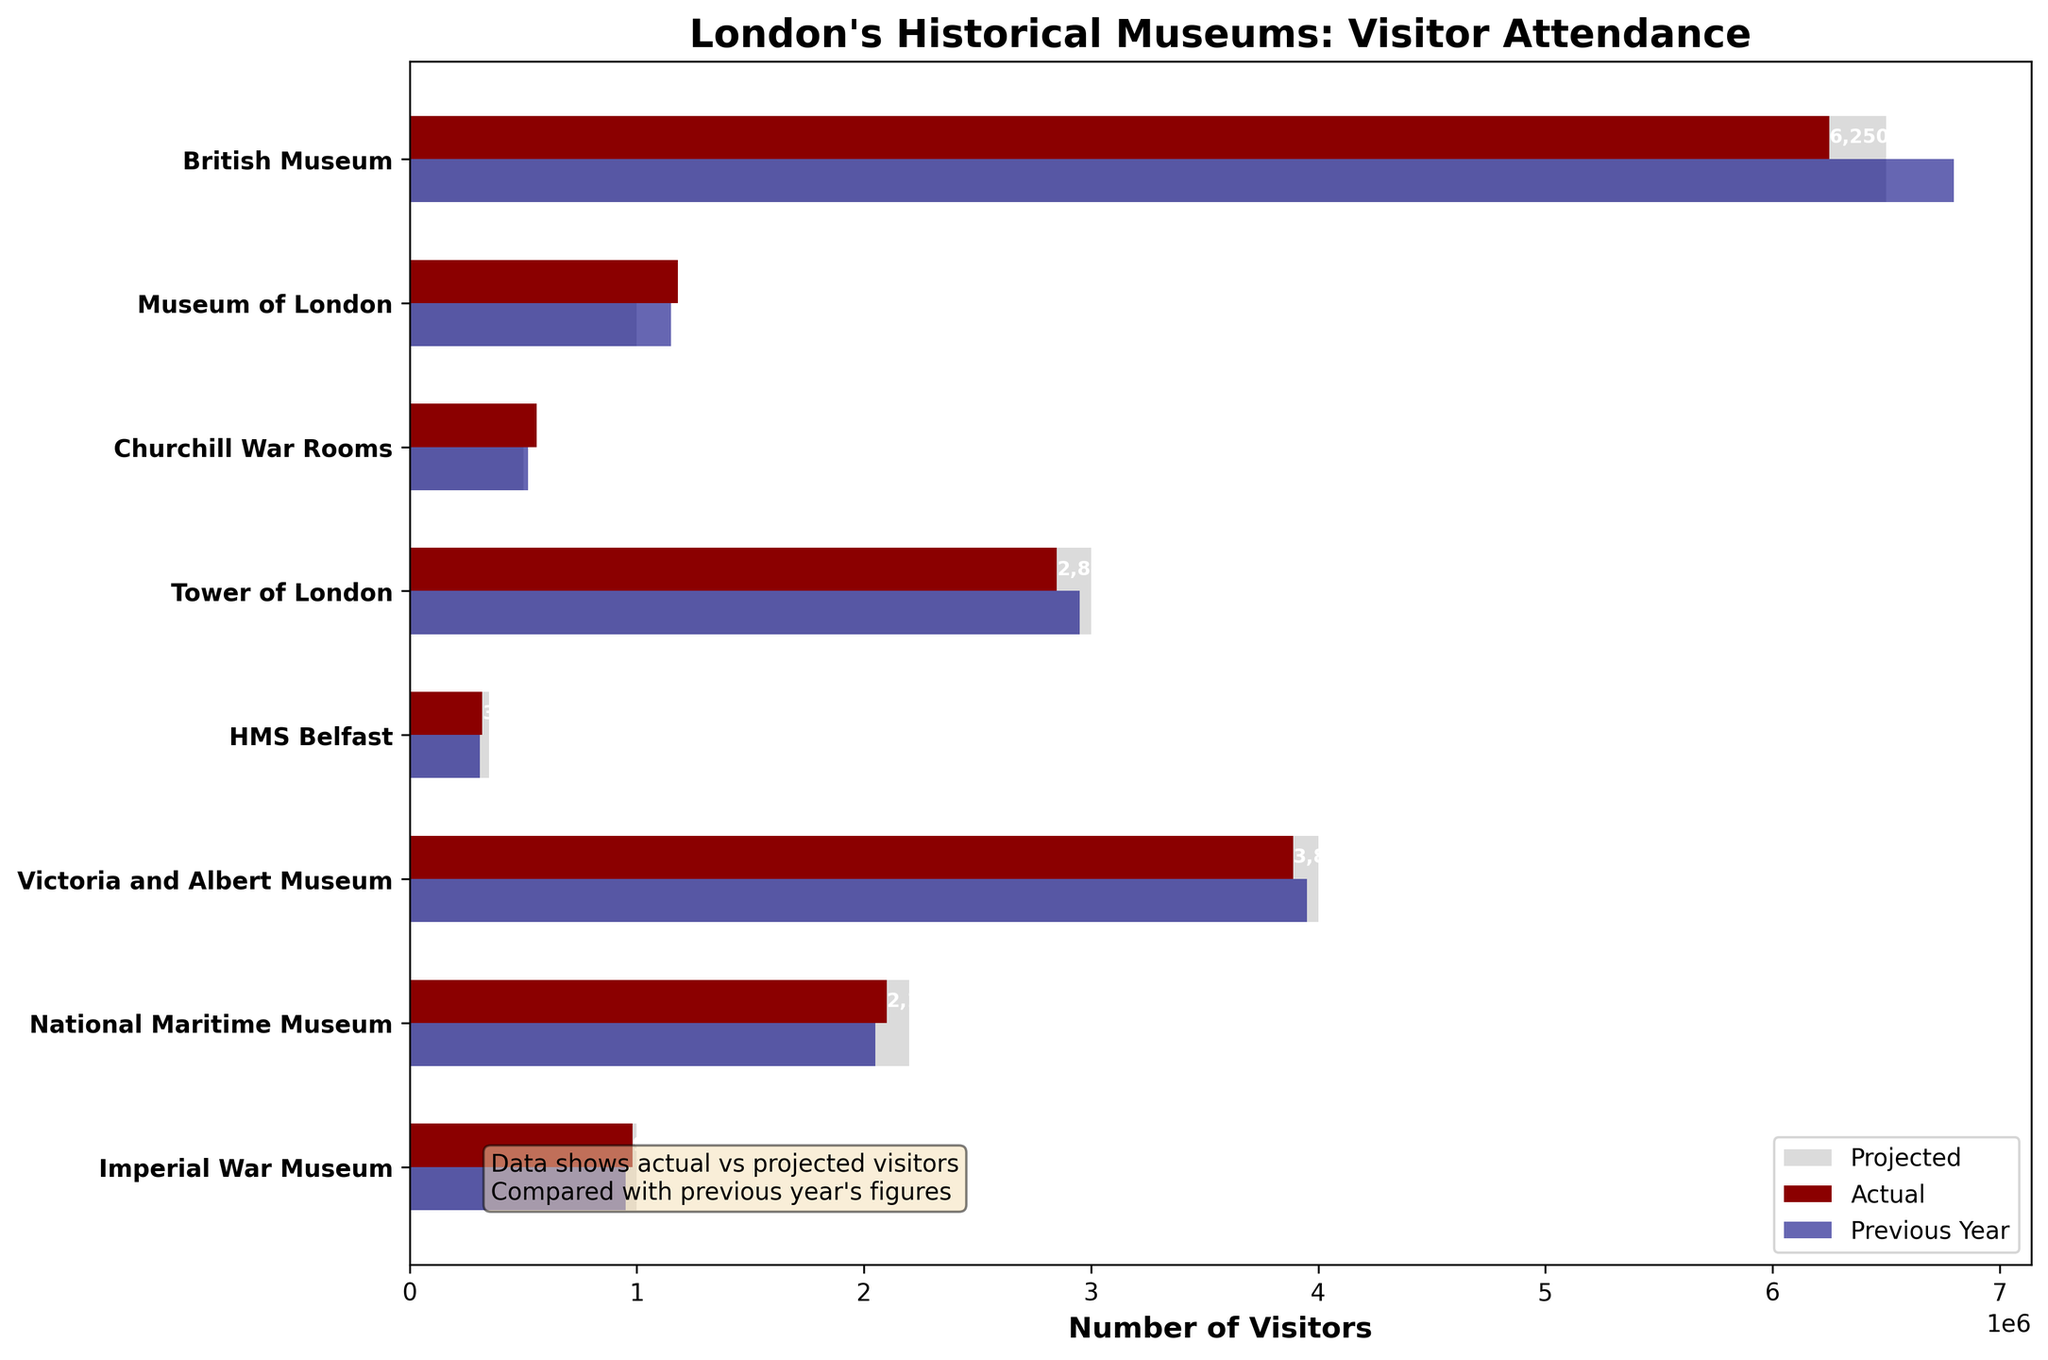What is the title of the chart? The title of the chart is typically found at the top of the figure and indicates the main topic or subject being represented. In this case, it should express what data is being displayed, specifically related to visitor attendance at London's historical museums.
Answer: London's Historical Museums: Visitor Attendance Which museum had the highest number of actual visitors? To determine the museum with the highest number of actual visitors, look for the bar labeled "Actual" (in dark red) that extends the furthest to the right on the chart.
Answer: British Museum How many visitors did the National Maritime Museum have the previous year? The previous year's visitors are represented by the navy-colored bar. Locate the bar associated with the National Maritime Museum and read its value.
Answer: 2,050,000 Compare the actual visitors of the Victoria and Albert Museum to its projected visitors. Was the actual number higher or lower? Compare the length of the dark red bar (actual visitors) to the light grey bar (projected visitors) for the Victoria and Albert Museum. If the dark red bar is shorter, the actual number is lower; if longer, the actual number is higher.
Answer: Lower Which museum had the closest actual visitor number to its projected visitors? Identify the actual visitor numbers (dark red bars) and projected visitor numbers (light grey bars) that are closest in length to each other. Calculate the differences to determine which is the closest.
Answer: Imperial War Museum For the Museum of London, how many more actual visitors were there compared to the previous year? Find the bars representing the actual visitors and previous year visitors for the Museum of London. Subtract the number of previous year visitors from the actual visitors to find the difference.
Answer: 30,000 Which museum had a higher increase in actual visitors compared to the previous year, Churchill War Rooms or HMS Belfast? Calculate the difference between actual visitors and previous year visitors for both Churchill War Rooms and HMS Belfast. The museum with the larger positive difference had a higher increase in actual visitors.
Answer: Churchill War Rooms How many museums had a higher number of actual visitors than their projected visitors? Compare the actual visitors (dark red bars) against the projected visitors (light grey bars) for each museum. Count how many times the actual visitors exceed the projected visitors.
Answer: 4 What is the total number of projected visitors across all museums? Sum the values of the projected visitors (light grey bars) for all museums to find the total.
Answer: 18,500,000 By how much did the actual visitors to the Tower of London fall short of its projected visitors? Subtract the number of actual visitors from the projected visitors for the Tower of London to determine the shortfall.
Answer: 150,000 Rank the museums in descending order based on actual visitor numbers. Arrange the museums by the length of their dark red bars (actual visitors) from longest to shortest. The sequence will show the descending order of actual visitor numbers.
Answer: British Museum, Victoria and Albert Museum, Tower of London, National Maritime Museum, Museum of London, Imperial War Museum, Churchill War Rooms, HMS Belfast 